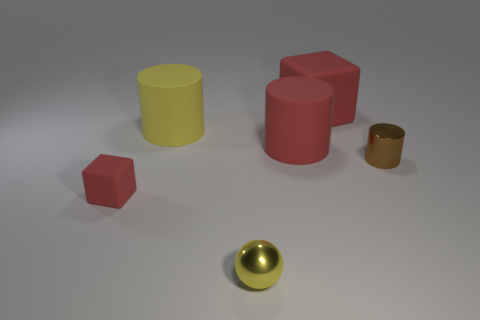How many things are rubber cubes or matte objects left of the big cube?
Provide a succinct answer. 4. The tiny brown shiny thing is what shape?
Ensure brevity in your answer.  Cylinder. The shiny object that is right of the red rubber cube that is right of the small matte thing is what shape?
Your answer should be very brief. Cylinder. What is the color of the other cube that is made of the same material as the big cube?
Give a very brief answer. Red. There is a cylinder that is left of the tiny sphere; is it the same color as the metal sphere that is right of the big yellow matte object?
Offer a terse response. Yes. Is the number of brown metallic cylinders behind the yellow matte cylinder greater than the number of small shiny things left of the big red cylinder?
Ensure brevity in your answer.  No. What color is the other large thing that is the same shape as the yellow matte object?
Your answer should be compact. Red. Are there any other things that are the same shape as the tiny yellow object?
Make the answer very short. No. Do the big yellow rubber object and the large thing that is behind the yellow matte object have the same shape?
Keep it short and to the point. No. How many other objects are there of the same material as the yellow sphere?
Your response must be concise. 1. 